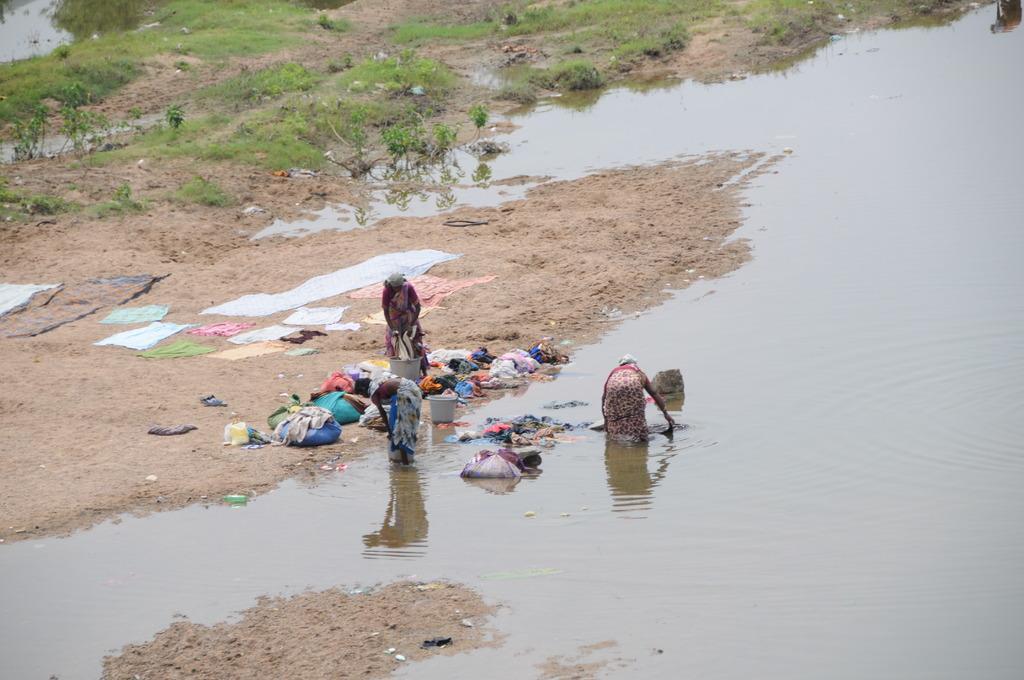How would you summarize this image in a sentence or two? In this picture we can see two women standing in the water. In front of the women, there are clothes, buckets and another woman on the sand. At the top of the image, there are plants and grass. 